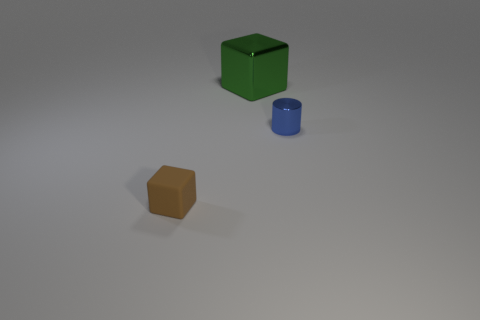Is there any other thing that has the same shape as the blue metallic object?
Provide a succinct answer. No. Are there any other things that are the same size as the green cube?
Ensure brevity in your answer.  No. Is there another blue thing of the same size as the matte thing?
Provide a succinct answer. Yes. How many tiny brown matte objects are there?
Offer a very short reply. 1. What number of tiny objects are brown cubes or gray shiny blocks?
Ensure brevity in your answer.  1. There is a tiny object behind the thing that is in front of the tiny object on the right side of the big green shiny block; what color is it?
Your answer should be compact. Blue. What number of other objects are there of the same color as the small matte cube?
Offer a terse response. 0. How many metallic things are either small things or large green objects?
Provide a succinct answer. 2. Do the block to the right of the tiny brown block and the shiny object that is on the right side of the large green object have the same color?
Provide a short and direct response. No. Is there any other thing that is the same material as the green block?
Give a very brief answer. Yes. 